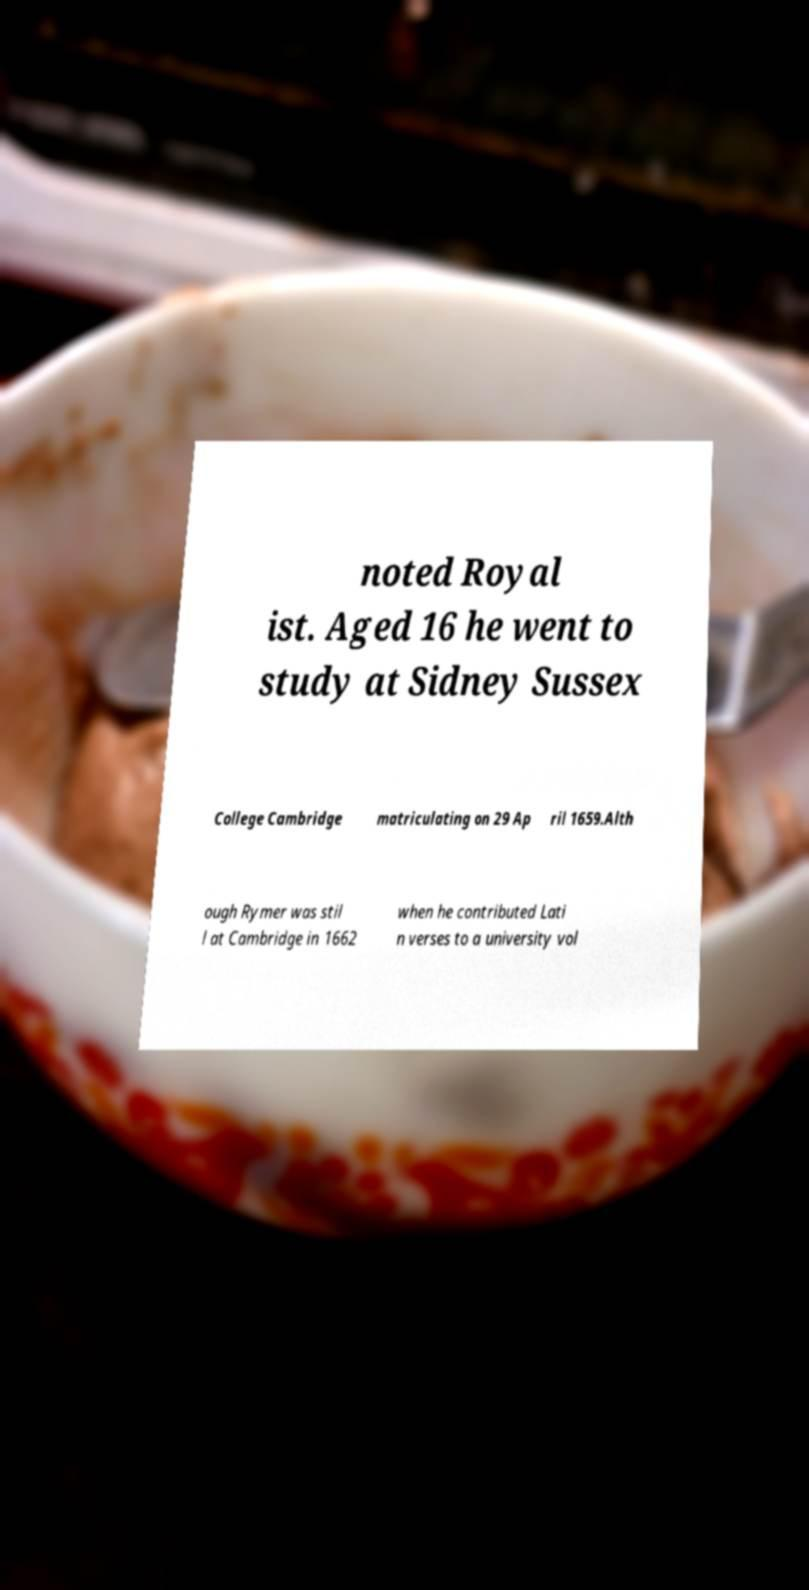Can you accurately transcribe the text from the provided image for me? noted Royal ist. Aged 16 he went to study at Sidney Sussex College Cambridge matriculating on 29 Ap ril 1659.Alth ough Rymer was stil l at Cambridge in 1662 when he contributed Lati n verses to a university vol 